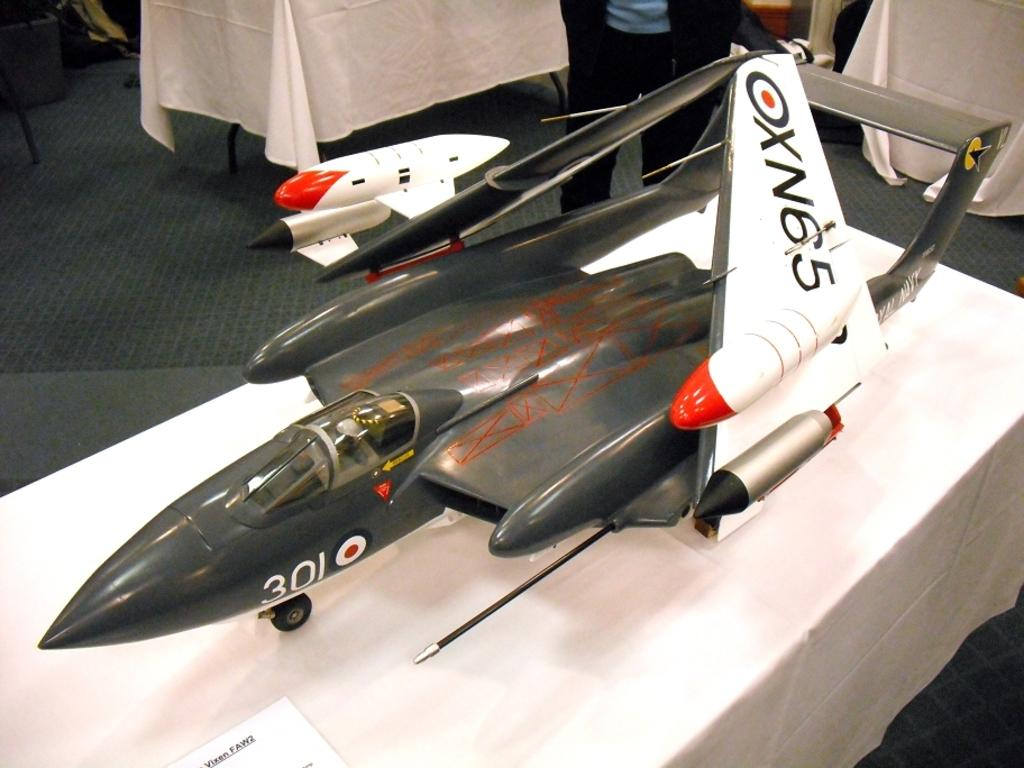Provide a one-sentence caption for the provided image. A model airplane sitting on a white table with OXN65 written on the wing. 